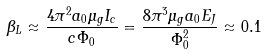<formula> <loc_0><loc_0><loc_500><loc_500>\beta _ { L } \approx \frac { 4 \pi ^ { 2 } a _ { 0 } \mu _ { g } I _ { c } } { c \Phi _ { 0 } } = \frac { 8 \pi ^ { 3 } \mu _ { g } a _ { 0 } E _ { J } } { \Phi _ { 0 } ^ { 2 } } \approx 0 . 1</formula> 